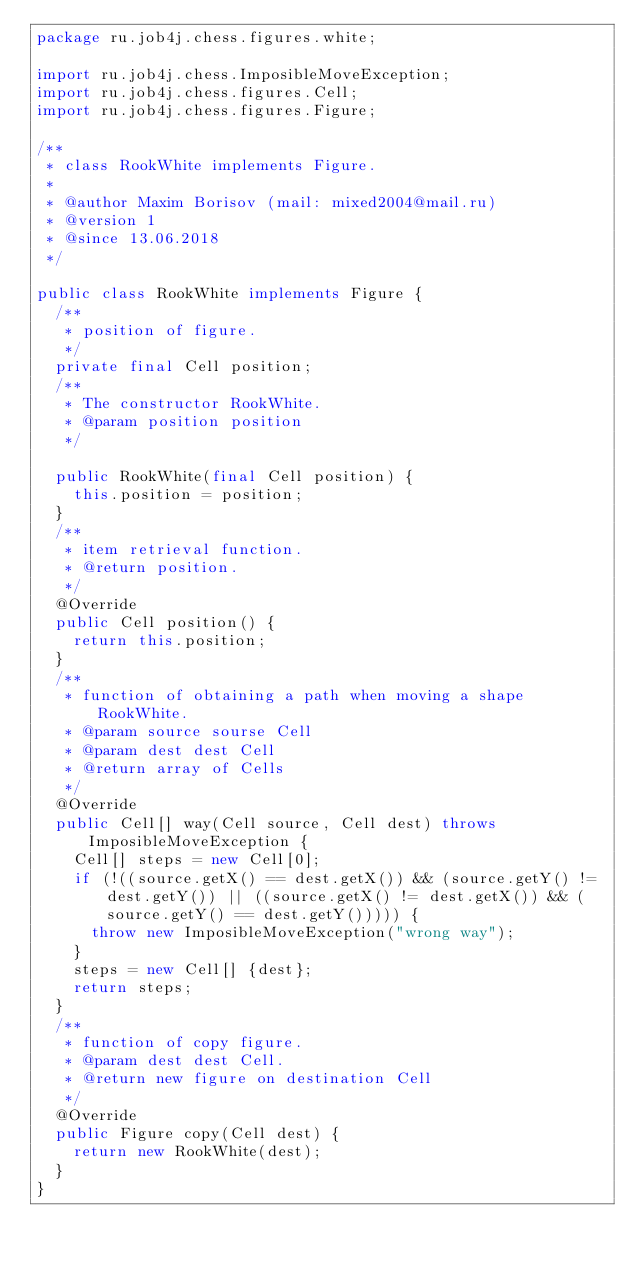<code> <loc_0><loc_0><loc_500><loc_500><_Java_>package ru.job4j.chess.figures.white;

import ru.job4j.chess.ImposibleMoveException;
import ru.job4j.chess.figures.Cell;
import ru.job4j.chess.figures.Figure;

/**
 * class RookWhite implements Figure.
 *
 * @author Maxim Borisov (mail: mixed2004@mail.ru)
 * @version 1
 * @since 13.06.2018
 */

public class RookWhite implements Figure {
  /**
   * position of figure.
   */
  private final Cell position;
  /**
   * The constructor RookWhite.
   * @param position position
   */

  public RookWhite(final Cell position) {
    this.position = position;
  }
  /**
   * item retrieval function.
   * @return position.
   */
  @Override
  public Cell position() {
    return this.position;
  }
  /**
   * function of obtaining a path when moving a shape RookWhite.
   * @param source sourse Cell
   * @param dest dest Cell
   * @return array of Cells
   */
  @Override
  public Cell[] way(Cell source, Cell dest) throws ImposibleMoveException {
    Cell[] steps = new Cell[0];
    if (!((source.getX() == dest.getX()) && (source.getY() != dest.getY()) || ((source.getX() != dest.getX()) && (source.getY() == dest.getY())))) {
      throw new ImposibleMoveException("wrong way");
    }
    steps = new Cell[] {dest};
    return steps;
  }
  /**
   * function of copy figure.
   * @param dest dest Cell.
   * @return new figure on destination Cell
   */
  @Override
  public Figure copy(Cell dest) {
    return new RookWhite(dest);
  }
}</code> 